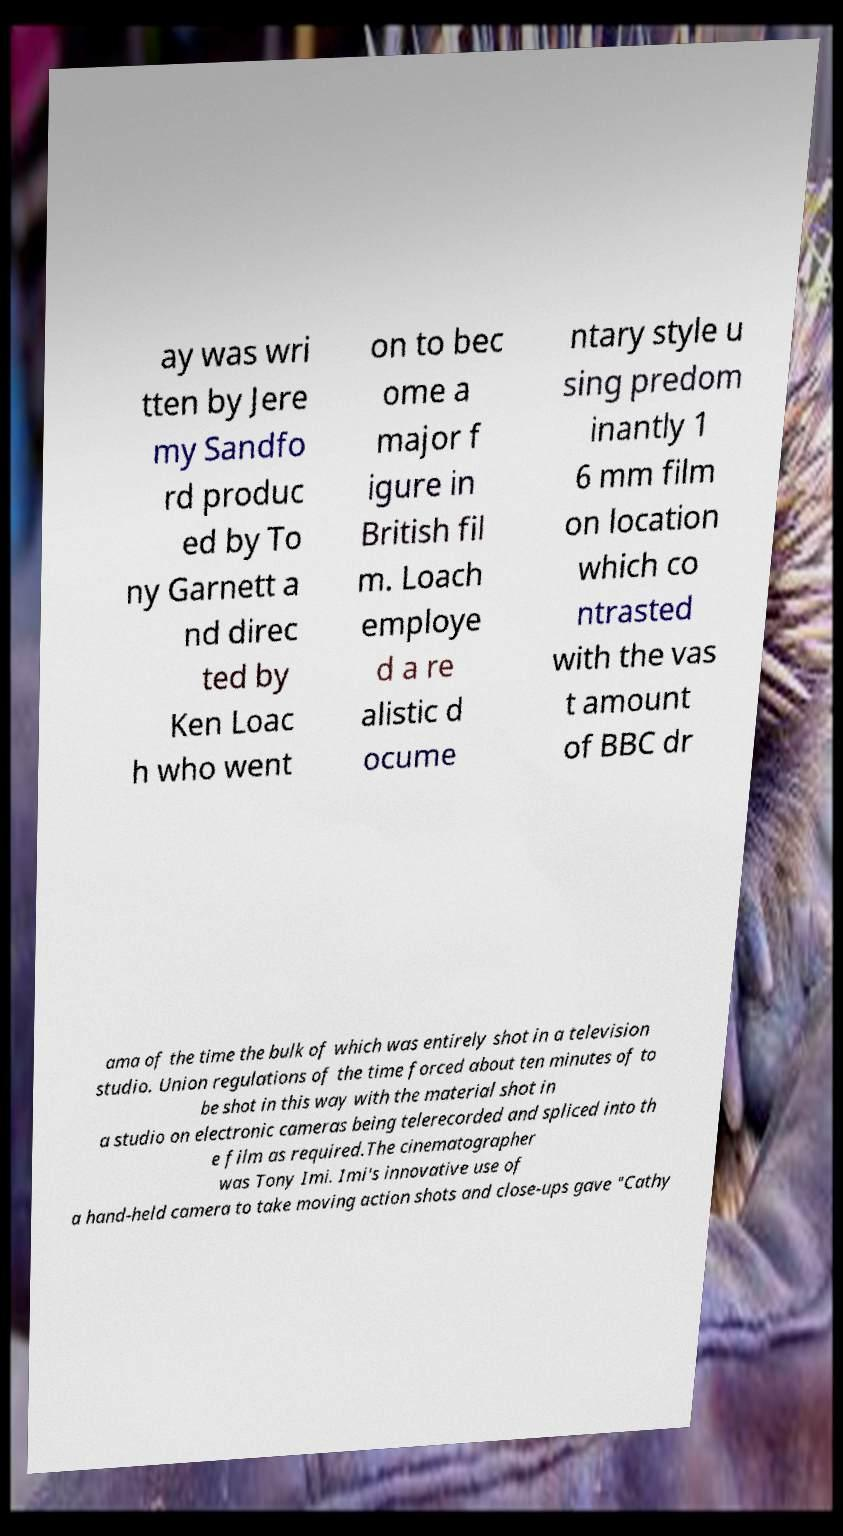Could you assist in decoding the text presented in this image and type it out clearly? ay was wri tten by Jere my Sandfo rd produc ed by To ny Garnett a nd direc ted by Ken Loac h who went on to bec ome a major f igure in British fil m. Loach employe d a re alistic d ocume ntary style u sing predom inantly 1 6 mm film on location which co ntrasted with the vas t amount of BBC dr ama of the time the bulk of which was entirely shot in a television studio. Union regulations of the time forced about ten minutes of to be shot in this way with the material shot in a studio on electronic cameras being telerecorded and spliced into th e film as required.The cinematographer was Tony Imi. Imi's innovative use of a hand-held camera to take moving action shots and close-ups gave "Cathy 